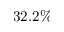<formula> <loc_0><loc_0><loc_500><loc_500>3 2 . 2 \%</formula> 